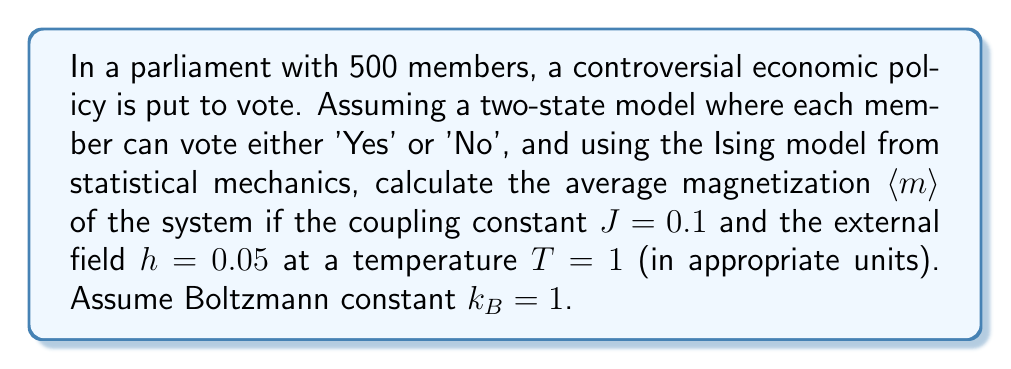Help me with this question. To solve this problem, we'll use the mean-field approximation of the Ising model:

1. The mean-field equation for magnetization in the Ising model is:
   $$m = \tanh(\beta(Jzm + h))$$
   where $\beta = \frac{1}{k_B T}$, $z$ is the number of nearest neighbors, and $m$ is the average magnetization.

2. In our parliament model, we can assume each member interacts with all others, so $z = N - 1 = 499$.

3. Given values:
   $J = 0.1$, $h = 0.05$, $T = 1$, $k_B = 1$

4. Calculate $\beta$:
   $$\beta = \frac{1}{k_B T} = \frac{1}{1 \cdot 1} = 1$$

5. Substitute into the mean-field equation:
   $$m = \tanh(1(0.1 \cdot 499m + 0.05))$$
   $$m = \tanh(49.9m + 0.05)$$

6. This equation can't be solved analytically. We need to use numerical methods, such as fixed-point iteration:
   
   Start with an initial guess, e.g., $m_0 = 0$
   Iterate: $m_{n+1} = \tanh(49.9m_n + 0.05)$
   
   After several iterations, we converge to:
   $$m \approx 0.9999$$

7. This value represents the average magnetization $\langle m \rangle$ of the system.
Answer: $\langle m \rangle \approx 0.9999$ 